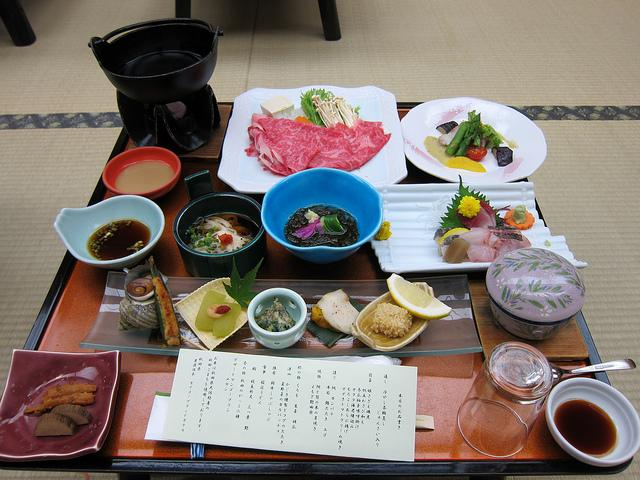Which food will add an acidic flavor to the food?

Choices:
A) meat
B) lemon
C) soy sauce
D) miso lemon 